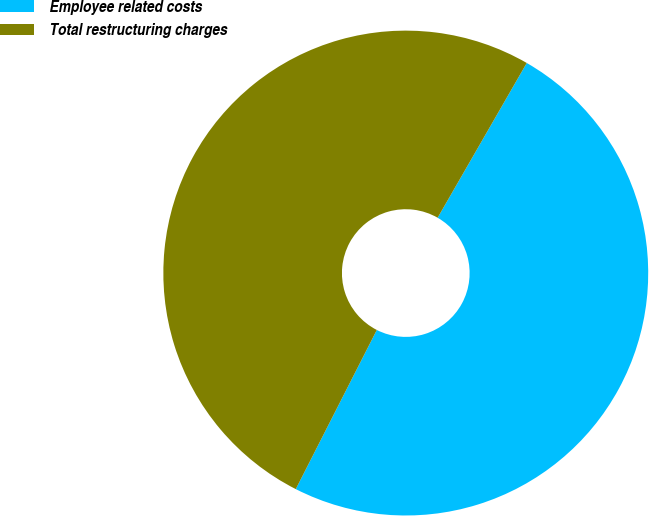<chart> <loc_0><loc_0><loc_500><loc_500><pie_chart><fcel>Employee related costs<fcel>Total restructuring charges<nl><fcel>49.18%<fcel>50.82%<nl></chart> 